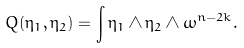<formula> <loc_0><loc_0><loc_500><loc_500>Q ( \eta _ { 1 } , \eta _ { 2 } ) = \int \eta _ { 1 } \wedge \eta _ { 2 } \wedge \omega ^ { n - 2 k } .</formula> 